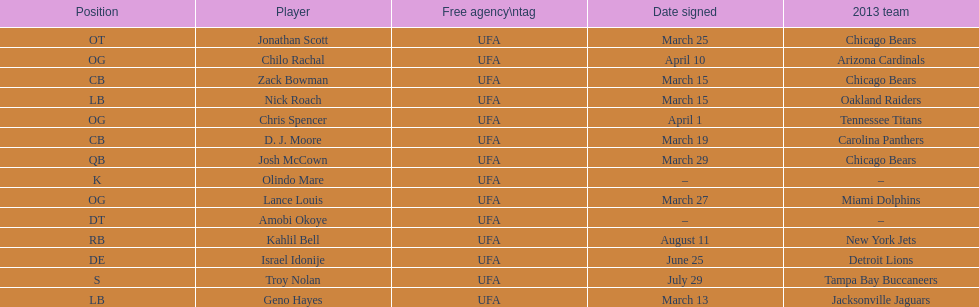Signed the same date as "april fools day". Chris Spencer. Can you parse all the data within this table? {'header': ['Position', 'Player', 'Free agency\\ntag', 'Date signed', '2013 team'], 'rows': [['OT', 'Jonathan Scott', 'UFA', 'March 25', 'Chicago Bears'], ['OG', 'Chilo Rachal', 'UFA', 'April 10', 'Arizona Cardinals'], ['CB', 'Zack Bowman', 'UFA', 'March 15', 'Chicago Bears'], ['LB', 'Nick Roach', 'UFA', 'March 15', 'Oakland Raiders'], ['OG', 'Chris Spencer', 'UFA', 'April 1', 'Tennessee Titans'], ['CB', 'D. J. Moore', 'UFA', 'March 19', 'Carolina Panthers'], ['QB', 'Josh McCown', 'UFA', 'March 29', 'Chicago Bears'], ['K', 'Olindo Mare', 'UFA', '–', '–'], ['OG', 'Lance Louis', 'UFA', 'March 27', 'Miami Dolphins'], ['DT', 'Amobi Okoye', 'UFA', '–', '–'], ['RB', 'Kahlil Bell', 'UFA', 'August 11', 'New York Jets'], ['DE', 'Israel Idonije', 'UFA', 'June 25', 'Detroit Lions'], ['S', 'Troy Nolan', 'UFA', 'July 29', 'Tampa Bay Buccaneers'], ['LB', 'Geno Hayes', 'UFA', 'March 13', 'Jacksonville Jaguars']]} 